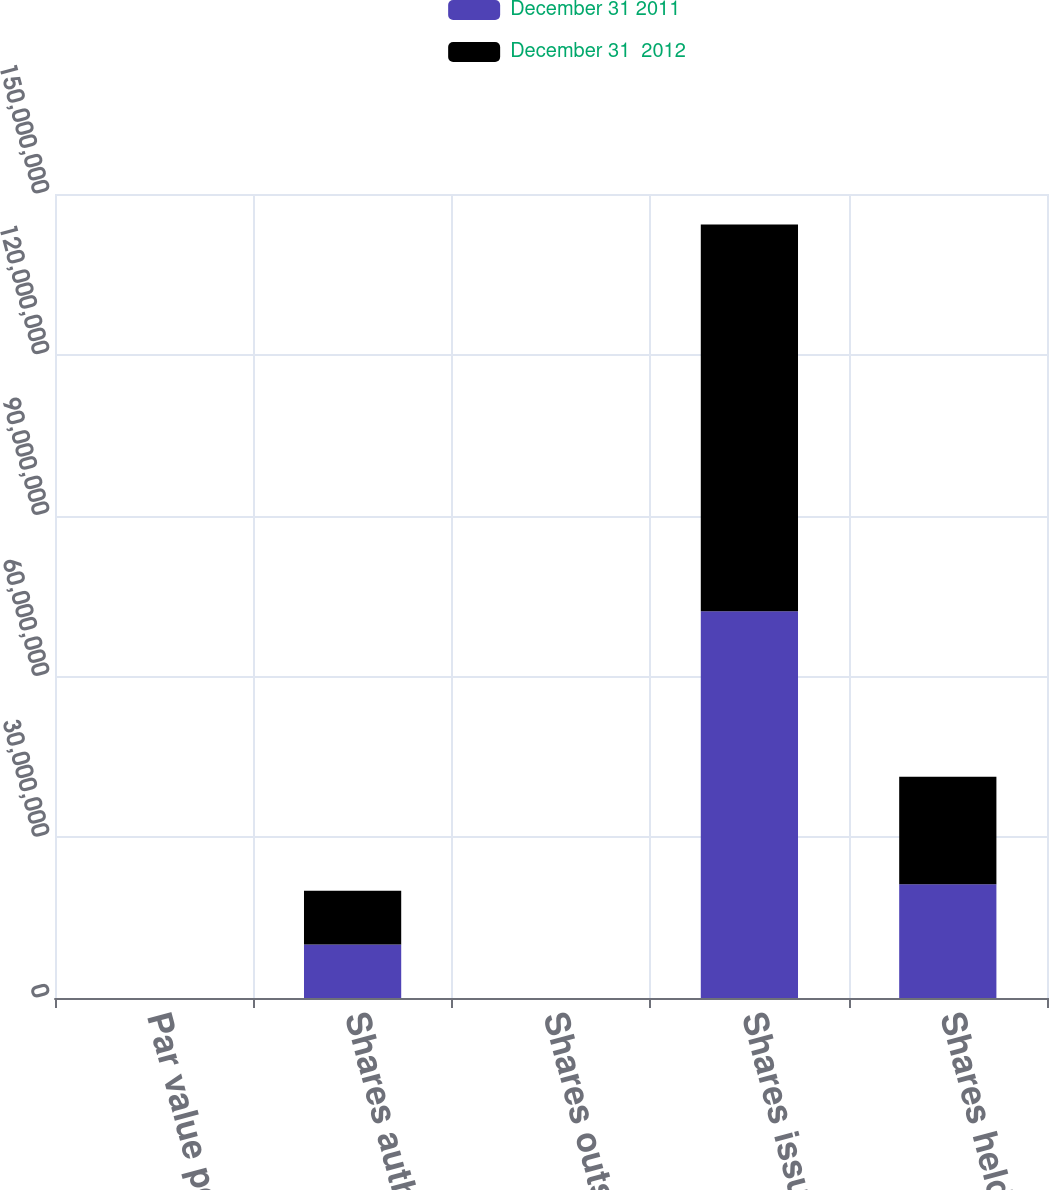Convert chart to OTSL. <chart><loc_0><loc_0><loc_500><loc_500><stacked_bar_chart><ecel><fcel>Par value per share<fcel>Shares authorized<fcel>Shares outstanding<fcel>Shares issued<fcel>Shares held<nl><fcel>December 31 2011<fcel>0.01<fcel>1e+07<fcel>0<fcel>7.21519e+07<fcel>2.12436e+07<nl><fcel>December 31  2012<fcel>0.01<fcel>1e+07<fcel>0<fcel>7.21519e+07<fcel>2.00567e+07<nl></chart> 